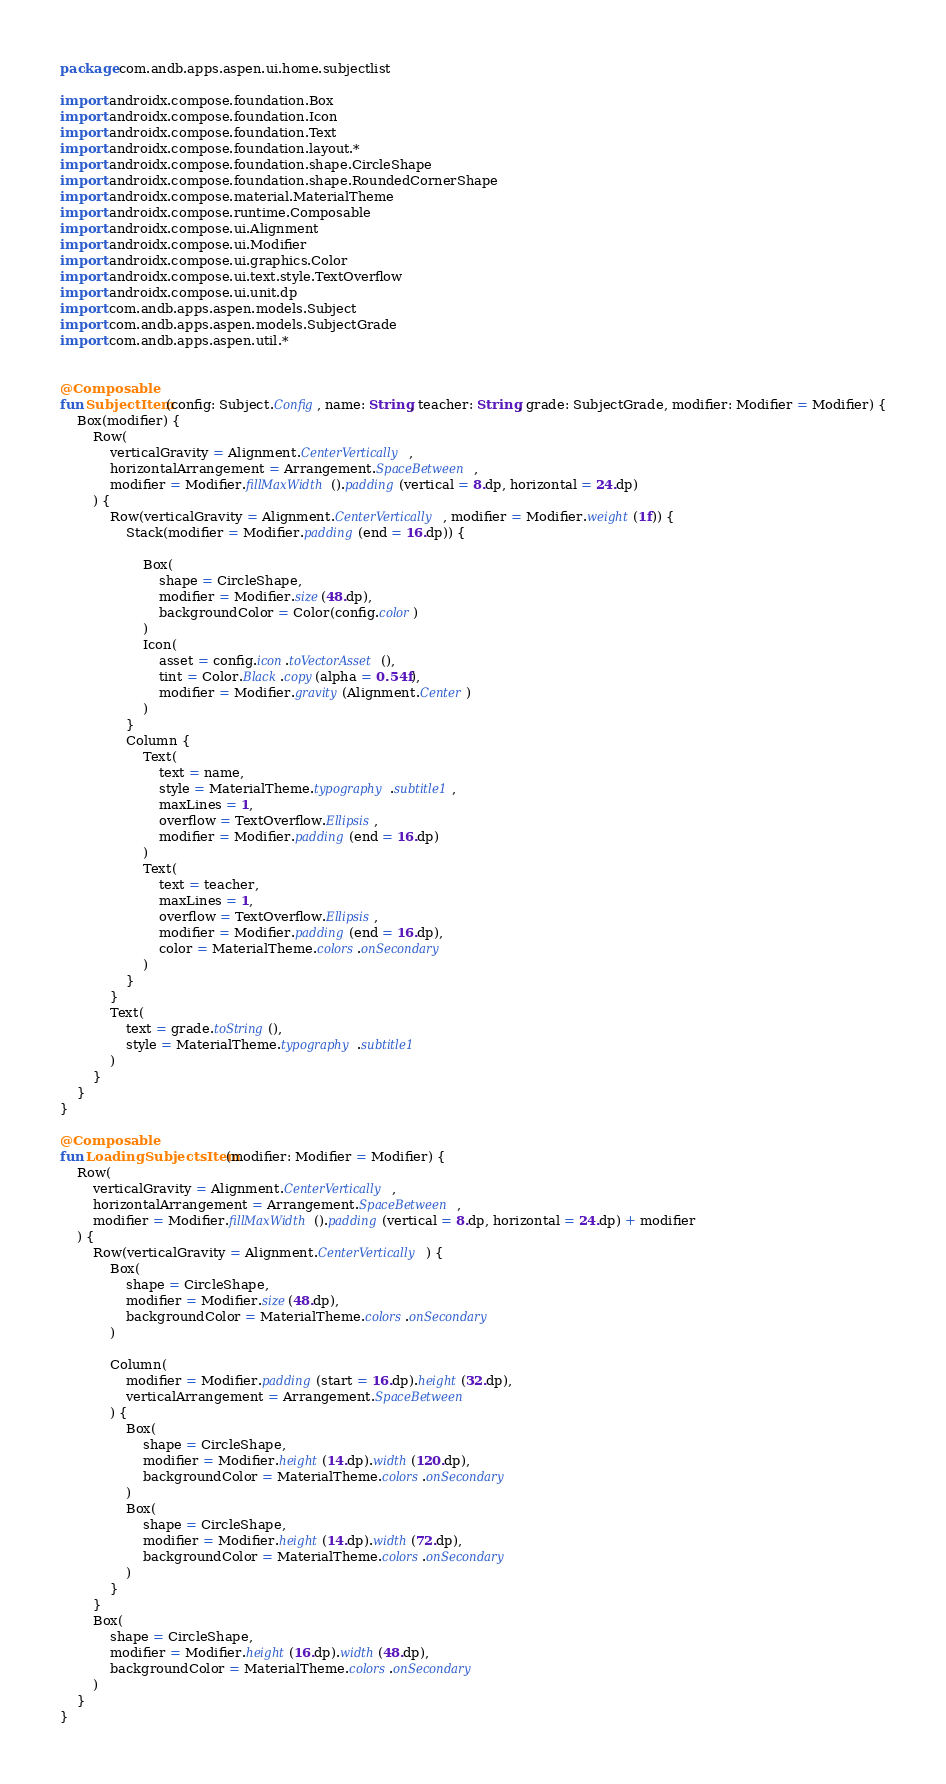<code> <loc_0><loc_0><loc_500><loc_500><_Kotlin_>package com.andb.apps.aspen.ui.home.subjectlist

import androidx.compose.foundation.Box
import androidx.compose.foundation.Icon
import androidx.compose.foundation.Text
import androidx.compose.foundation.layout.*
import androidx.compose.foundation.shape.CircleShape
import androidx.compose.foundation.shape.RoundedCornerShape
import androidx.compose.material.MaterialTheme
import androidx.compose.runtime.Composable
import androidx.compose.ui.Alignment
import androidx.compose.ui.Modifier
import androidx.compose.ui.graphics.Color
import androidx.compose.ui.text.style.TextOverflow
import androidx.compose.ui.unit.dp
import com.andb.apps.aspen.models.Subject
import com.andb.apps.aspen.models.SubjectGrade
import com.andb.apps.aspen.util.*


@Composable
fun SubjectItem(config: Subject.Config, name: String, teacher: String, grade: SubjectGrade, modifier: Modifier = Modifier) {
    Box(modifier) {
        Row(
            verticalGravity = Alignment.CenterVertically,
            horizontalArrangement = Arrangement.SpaceBetween,
            modifier = Modifier.fillMaxWidth().padding(vertical = 8.dp, horizontal = 24.dp)
        ) {
            Row(verticalGravity = Alignment.CenterVertically, modifier = Modifier.weight(1f)) {
                Stack(modifier = Modifier.padding(end = 16.dp)) {

                    Box(
                        shape = CircleShape,
                        modifier = Modifier.size(48.dp),
                        backgroundColor = Color(config.color)
                    )
                    Icon(
                        asset = config.icon.toVectorAsset(),
                        tint = Color.Black.copy(alpha = 0.54f),
                        modifier = Modifier.gravity(Alignment.Center)
                    )
                }
                Column {
                    Text(
                        text = name,
                        style = MaterialTheme.typography.subtitle1,
                        maxLines = 1,
                        overflow = TextOverflow.Ellipsis,
                        modifier = Modifier.padding(end = 16.dp)
                    )
                    Text(
                        text = teacher,
                        maxLines = 1,
                        overflow = TextOverflow.Ellipsis,
                        modifier = Modifier.padding(end = 16.dp),
                        color = MaterialTheme.colors.onSecondary
                    )
                }
            }
            Text(
                text = grade.toString(),
                style = MaterialTheme.typography.subtitle1
            )
        }
    }
}

@Composable
fun LoadingSubjectsItem(modifier: Modifier = Modifier) {
    Row(
        verticalGravity = Alignment.CenterVertically,
        horizontalArrangement = Arrangement.SpaceBetween,
        modifier = Modifier.fillMaxWidth().padding(vertical = 8.dp, horizontal = 24.dp) + modifier
    ) {
        Row(verticalGravity = Alignment.CenterVertically) {
            Box(
                shape = CircleShape,
                modifier = Modifier.size(48.dp),
                backgroundColor = MaterialTheme.colors.onSecondary
            )

            Column(
                modifier = Modifier.padding(start = 16.dp).height(32.dp),
                verticalArrangement = Arrangement.SpaceBetween
            ) {
                Box(
                    shape = CircleShape,
                    modifier = Modifier.height(14.dp).width(120.dp),
                    backgroundColor = MaterialTheme.colors.onSecondary
                )
                Box(
                    shape = CircleShape,
                    modifier = Modifier.height(14.dp).width(72.dp),
                    backgroundColor = MaterialTheme.colors.onSecondary
                )
            }
        }
        Box(
            shape = CircleShape,
            modifier = Modifier.height(16.dp).width(48.dp),
            backgroundColor = MaterialTheme.colors.onSecondary
        )
    }
}</code> 